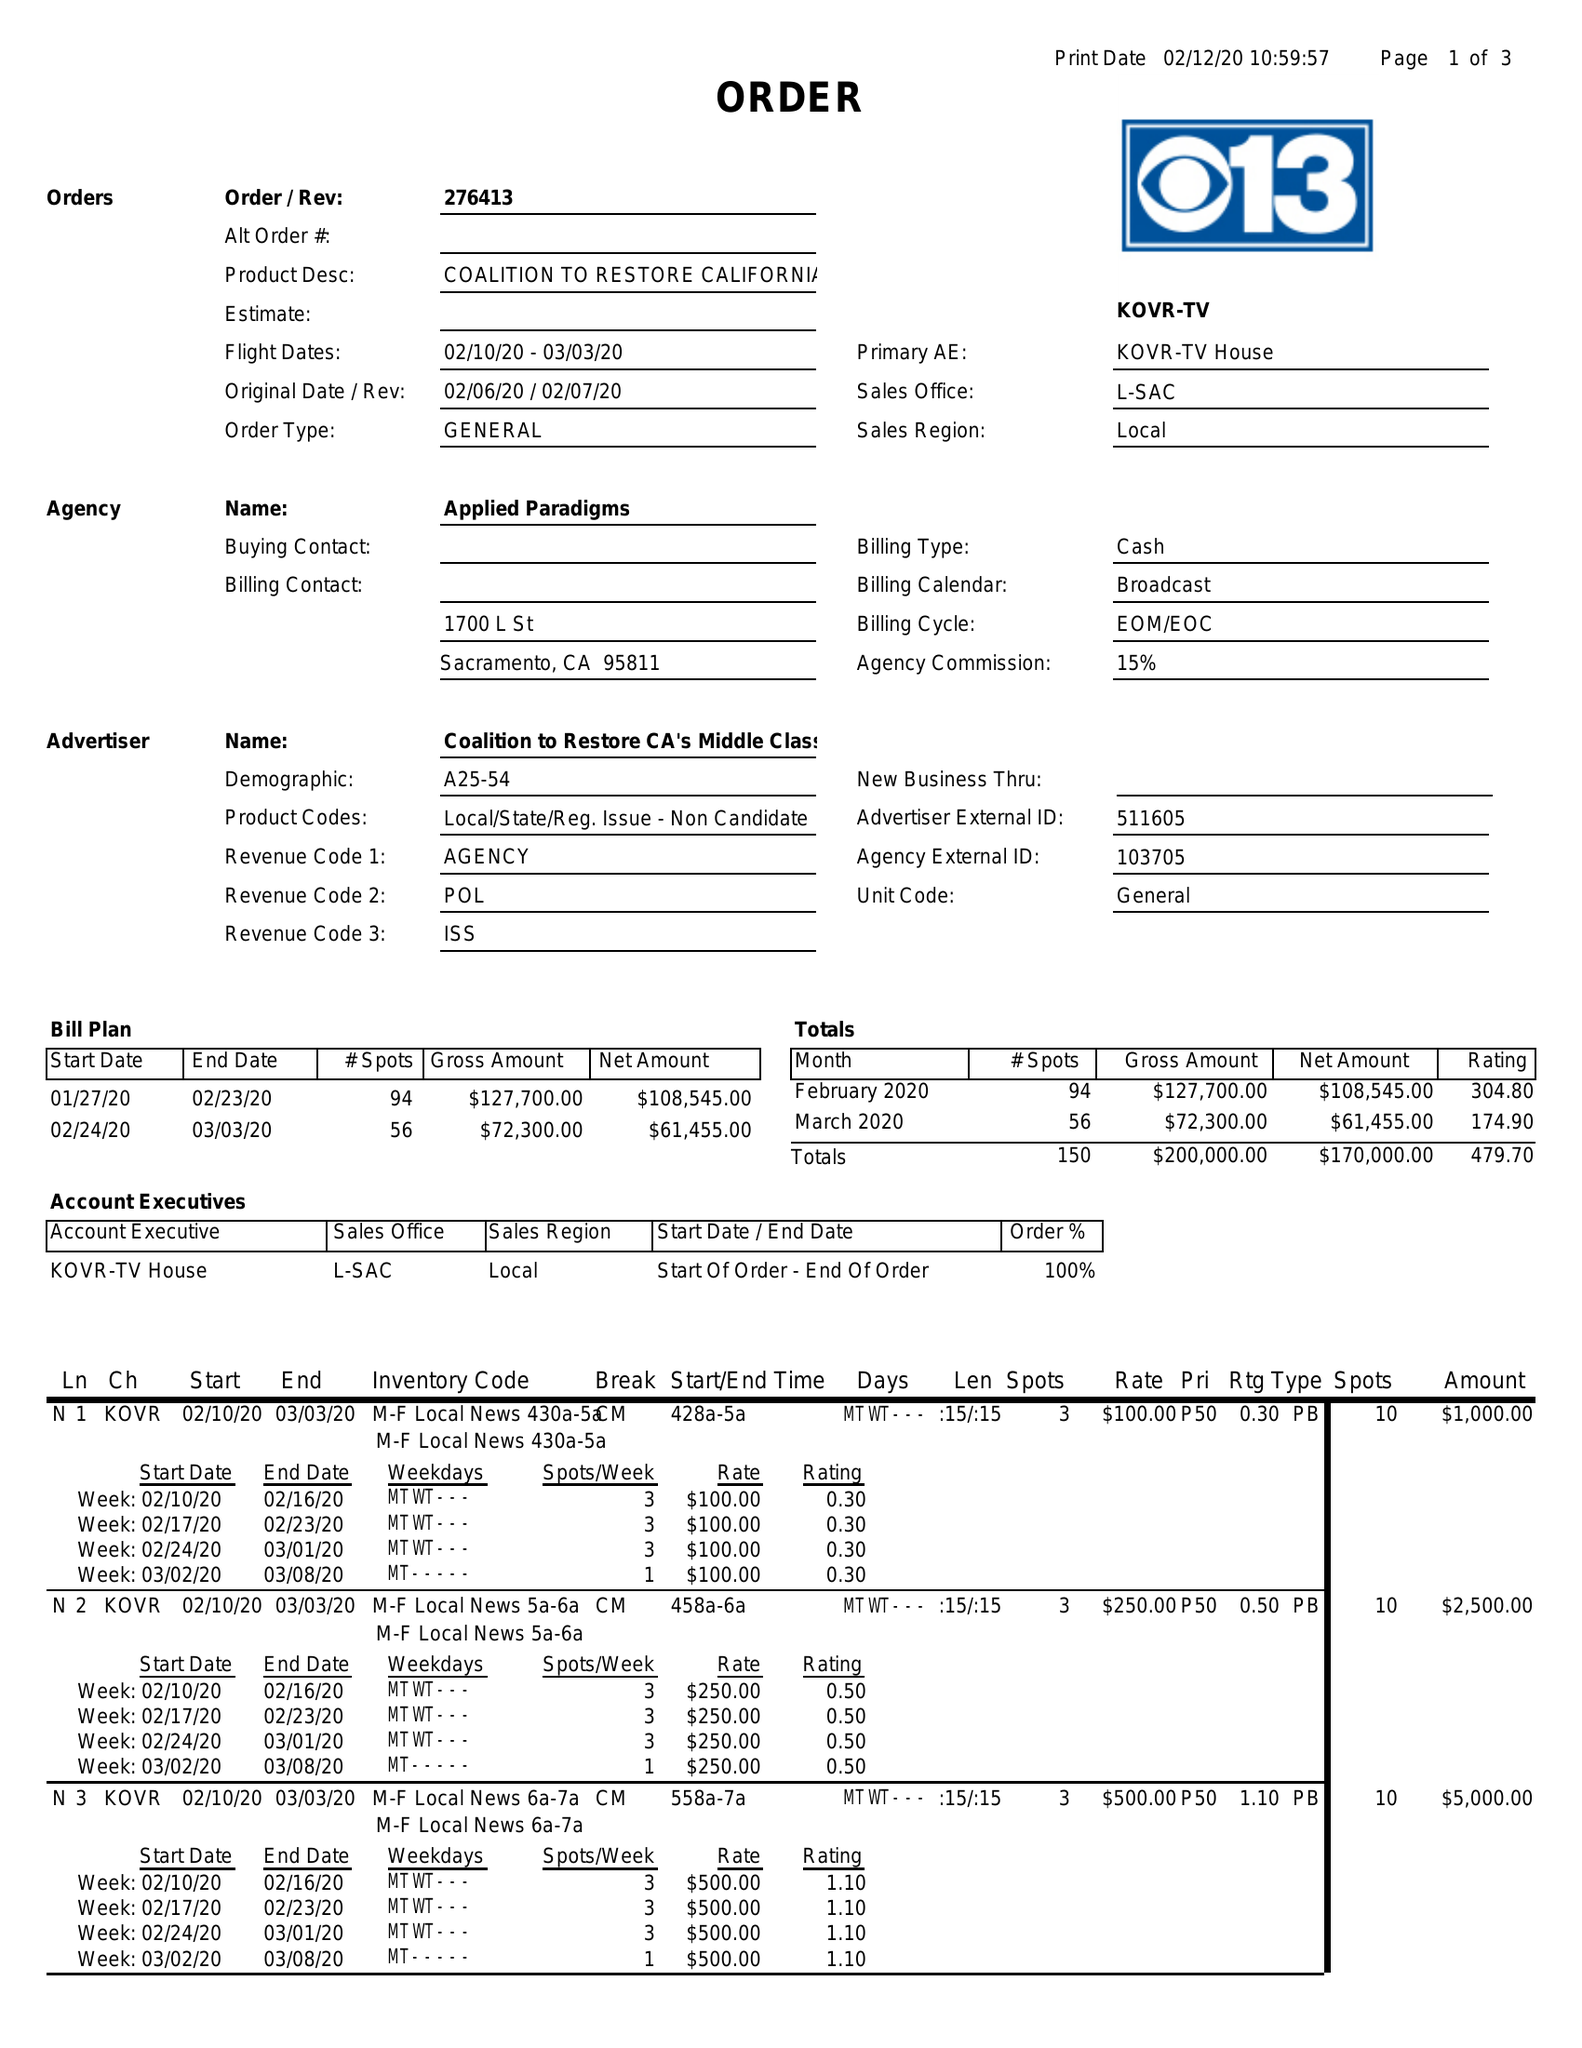What is the value for the flight_from?
Answer the question using a single word or phrase. 02/10/20 